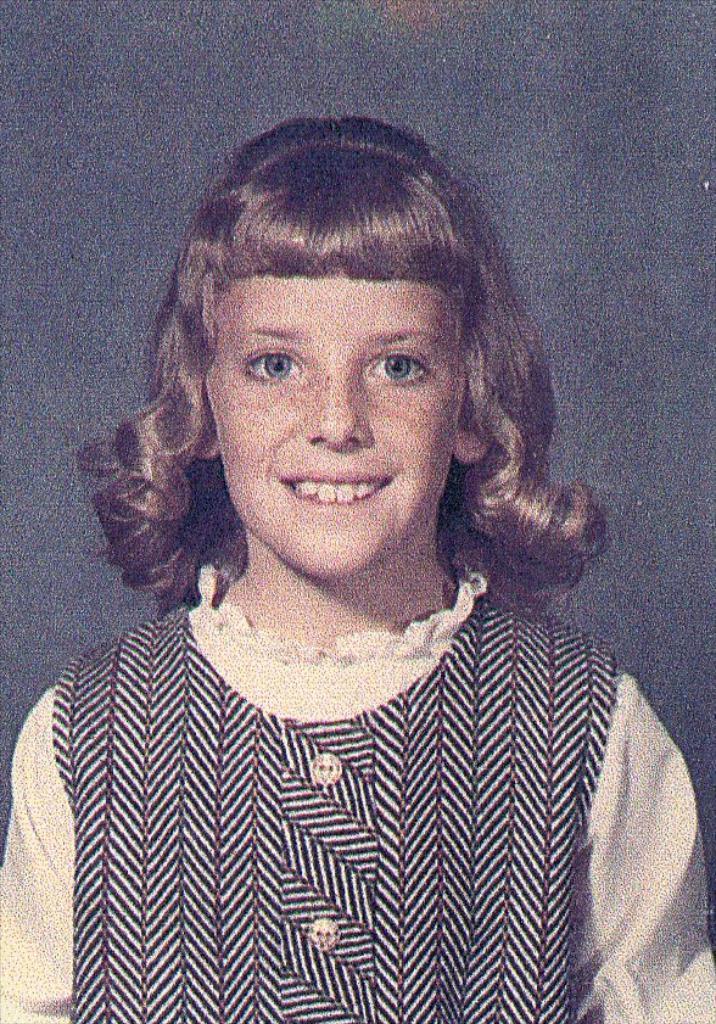Could you give a brief overview of what you see in this image? In this image there's a picture of a girl with a smile on her face. 